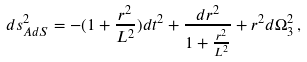Convert formula to latex. <formula><loc_0><loc_0><loc_500><loc_500>d s ^ { 2 } _ { A d S } = - ( 1 + \frac { r ^ { 2 } } { L ^ { 2 } } ) d t ^ { 2 } + \frac { d r ^ { 2 } } { 1 + \frac { r ^ { 2 } } { L ^ { 2 } } } + r ^ { 2 } d \Omega _ { 3 } ^ { 2 } \, ,</formula> 